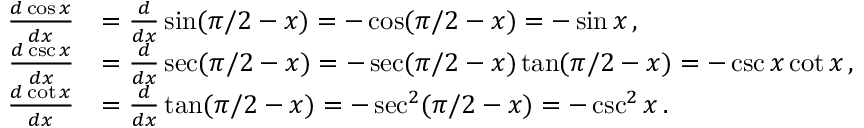Convert formula to latex. <formula><loc_0><loc_0><loc_500><loc_500>{ \begin{array} { r l } { { \frac { d \cos x } { d x } } } & { = { \frac { d } { d x } } \sin ( \pi / 2 - x ) = - \cos ( \pi / 2 - x ) = - \sin x \, , } \\ { { \frac { d \csc x } { d x } } } & { = { \frac { d } { d x } } \sec ( \pi / 2 - x ) = - \sec ( \pi / 2 - x ) \tan ( \pi / 2 - x ) = - \csc x \cot x \, , } \\ { { \frac { d \cot x } { d x } } } & { = { \frac { d } { d x } } \tan ( \pi / 2 - x ) = - \sec ^ { 2 } ( \pi / 2 - x ) = - \csc ^ { 2 } x \, . } \end{array} }</formula> 